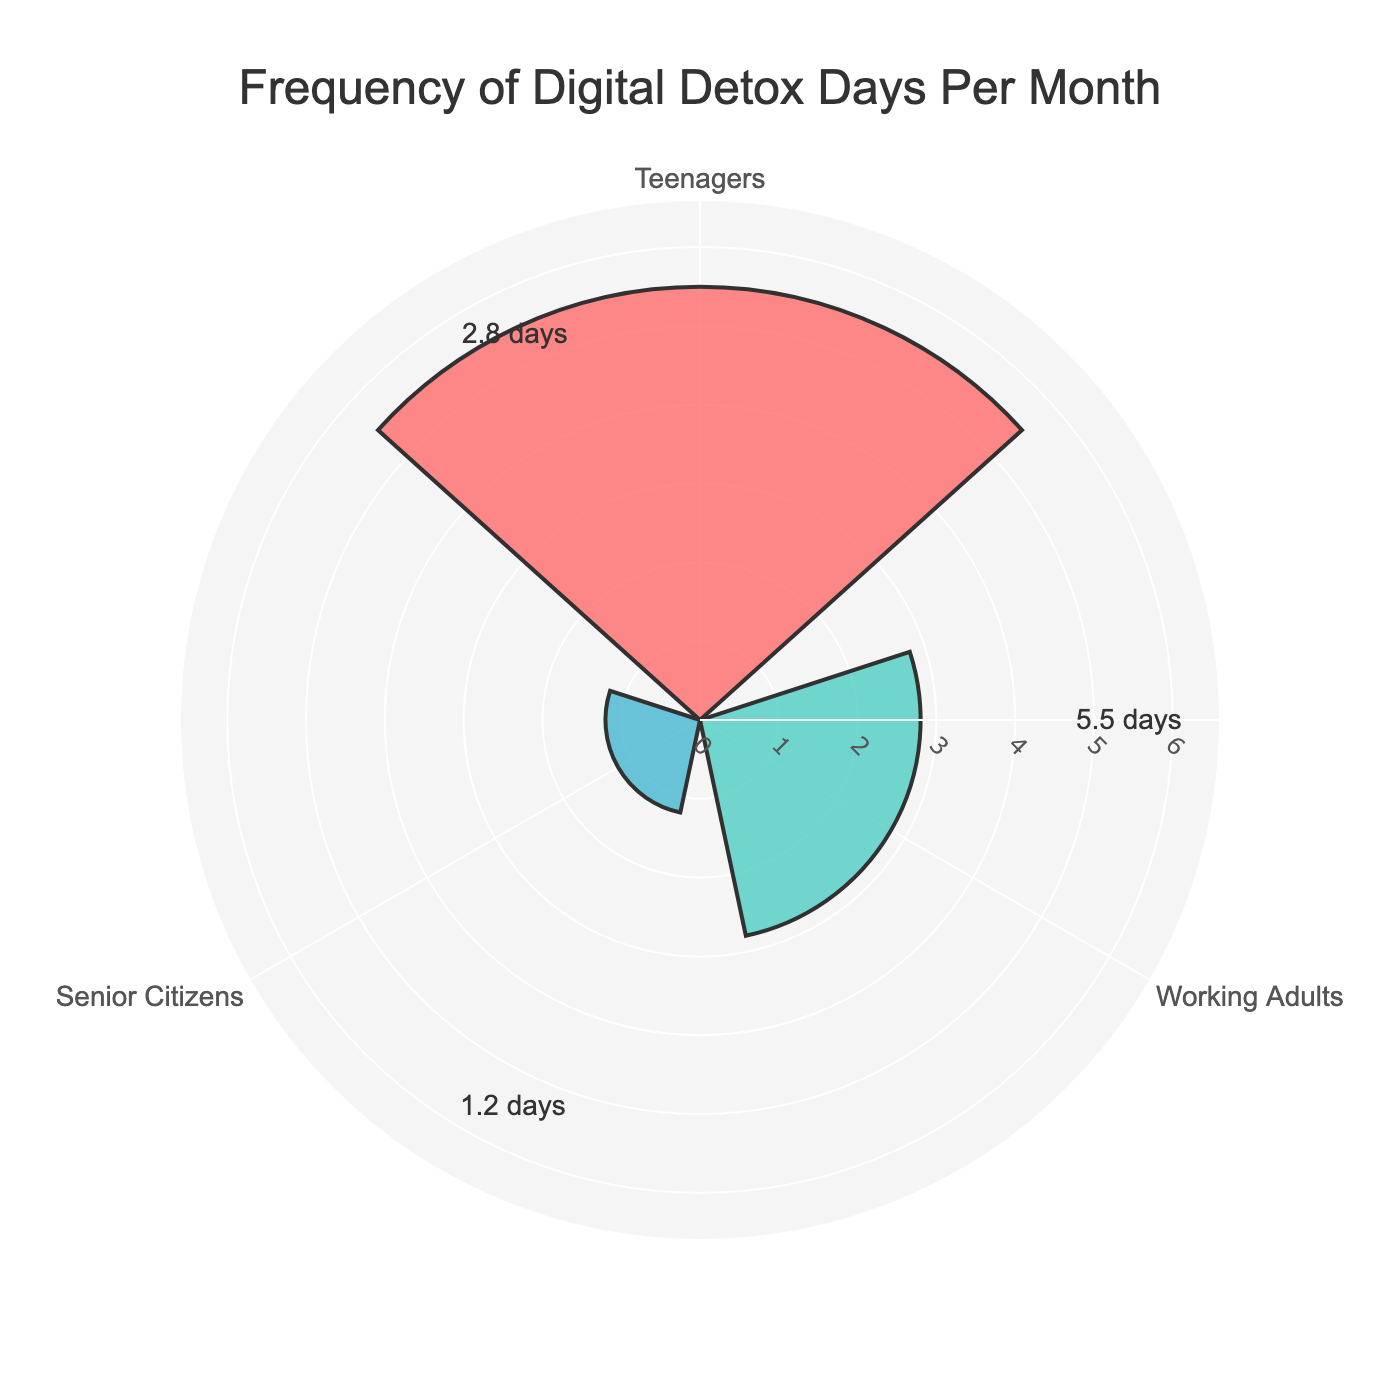What's the title of the plot? The title is located at the top of the plot. It's clearly stated and provides an overview of the visualized data.
Answer: Frequency of Digital Detox Days Per Month How many groups are represented in the chart? By visually inspecting the radial axis and observing the labels, we can count the distinct groups.
Answer: 3 Which group has the highest frequency of digital detox days? The group with the longest bar reaching the furthest from the center represents the highest frequency.
Answer: Teenagers Which group has the lowest frequency of digital detox days? The group with the shortest bar reaching the least distance from the center represents the lowest frequency.
Answer: Senior Citizens What's the difference in frequency of digital detox days between Teenagers and Working Adults? By subtracting the frequency of Working Adults from Teenagers (5.5 - 2.8), we get the difference.
Answer: 2.7 What is the average frequency of digital detox days per month across all groups? Sum the frequencies for all groups and divide by the number of groups: (5.5 + 2.8 + 1.2) / 3.
Answer: 3.17 How does the frequency of digital detox days for Senior Citizens compare to Working Adults? Compare the lengths of the bars representing these groups. Senior Citizens have a lower frequency than Working Adults.
Answer: Senior Citizens have fewer What color represents the Working Adults group? Each group is represented by a distinct color. Working Adults is the second group in the dataset.
Answer: Teal What range is used for the radial axis in the plot? The radial axis range is shown in the layout, starting from 0 up to a value 1.2 times the maximum frequency value found in the data (approximately 6.6).
Answer: 0 to 6.6 Is the bar for Teenagers longer than the combined length of the bars for Working Adults and Senior Citizens? Add the frequencies for Working Adults and Senior Citizens (2.8 + 1.2 = 4.0) and compare it to Teenagers (5.5).
Answer: Yes 